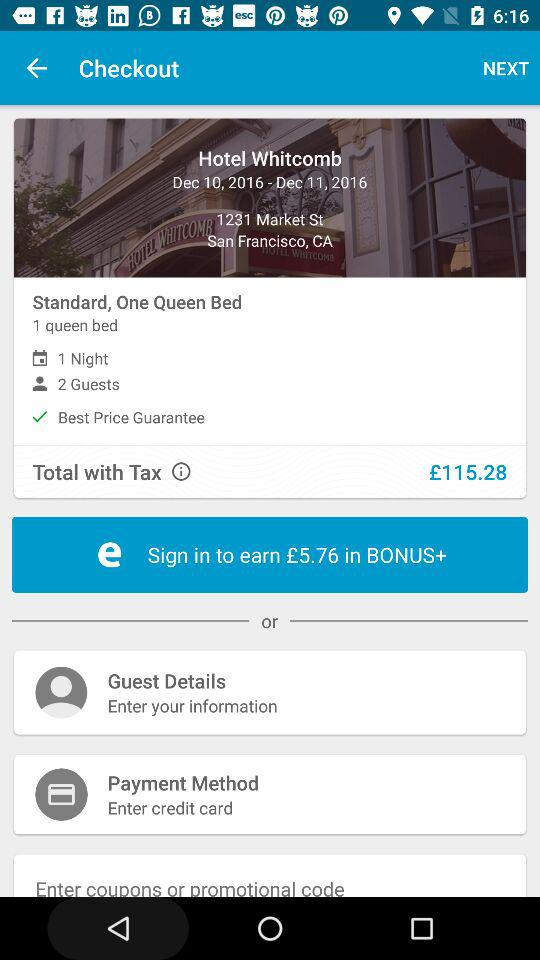What is the star rating of Beck Motor Lodge? The rating is 4.3 stars. 